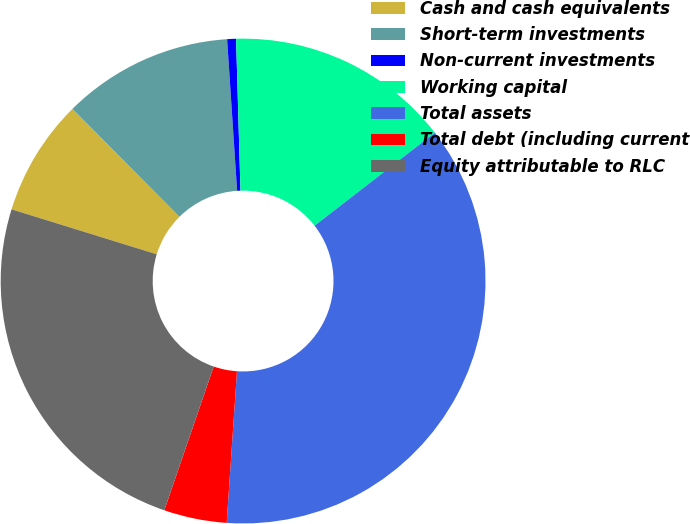<chart> <loc_0><loc_0><loc_500><loc_500><pie_chart><fcel>Cash and cash equivalents<fcel>Short-term investments<fcel>Non-current investments<fcel>Working capital<fcel>Total assets<fcel>Total debt (including current<fcel>Equity attributable to RLC<nl><fcel>7.79%<fcel>11.38%<fcel>0.59%<fcel>14.98%<fcel>36.56%<fcel>4.19%<fcel>24.51%<nl></chart> 